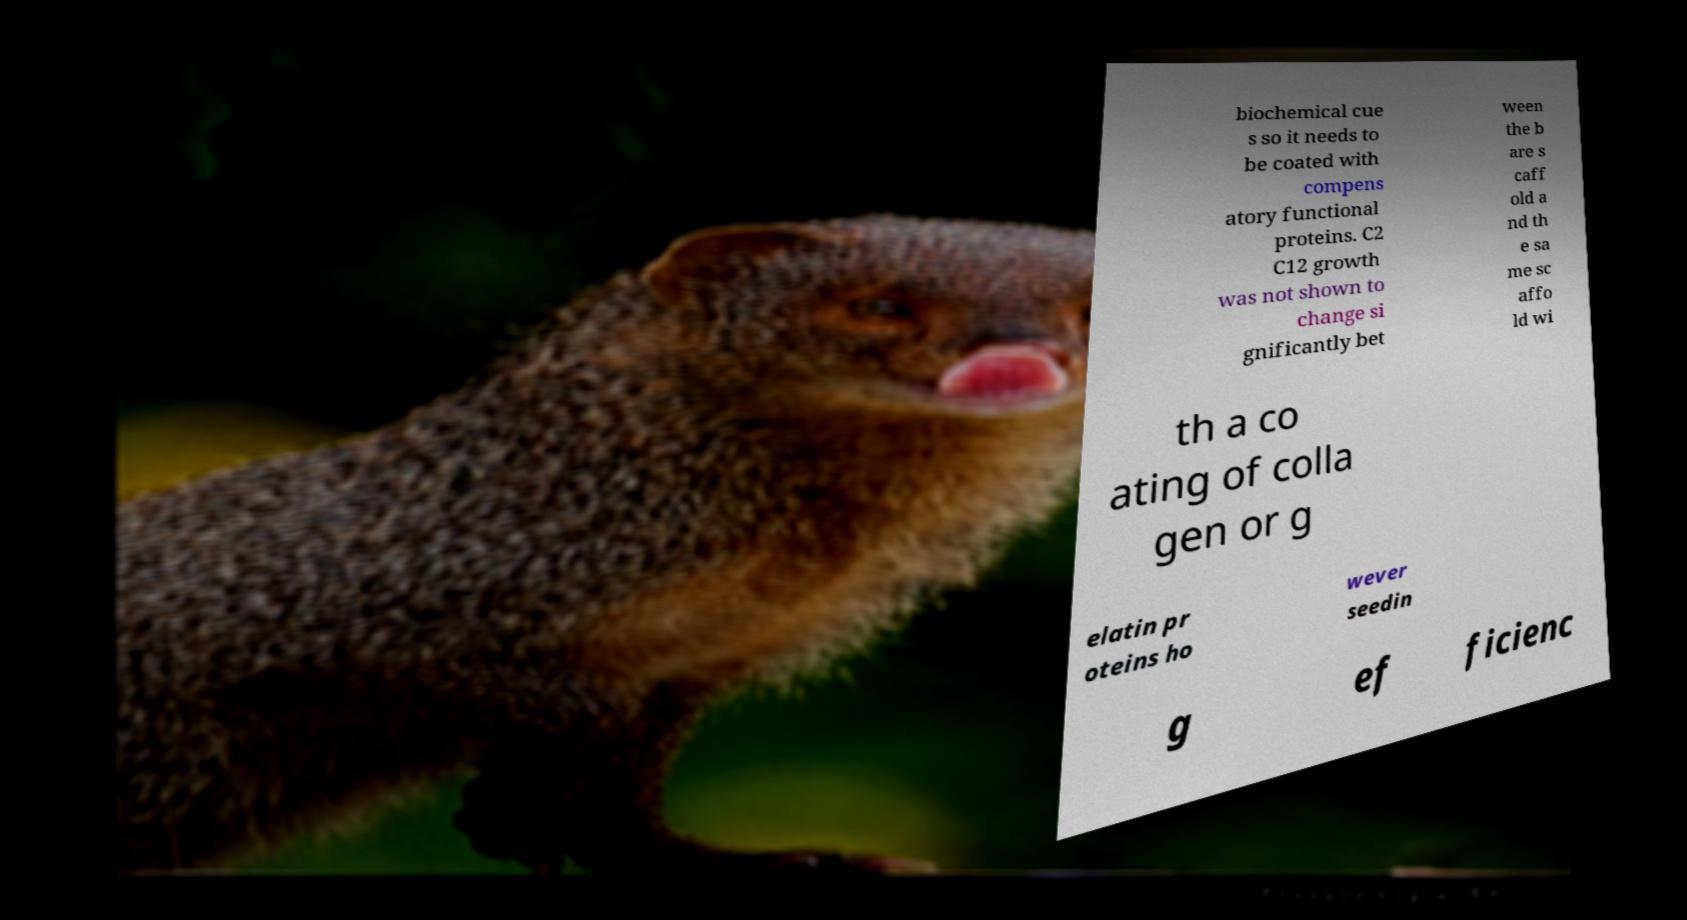There's text embedded in this image that I need extracted. Can you transcribe it verbatim? biochemical cue s so it needs to be coated with compens atory functional proteins. C2 C12 growth was not shown to change si gnificantly bet ween the b are s caff old a nd th e sa me sc affo ld wi th a co ating of colla gen or g elatin pr oteins ho wever seedin g ef ficienc 